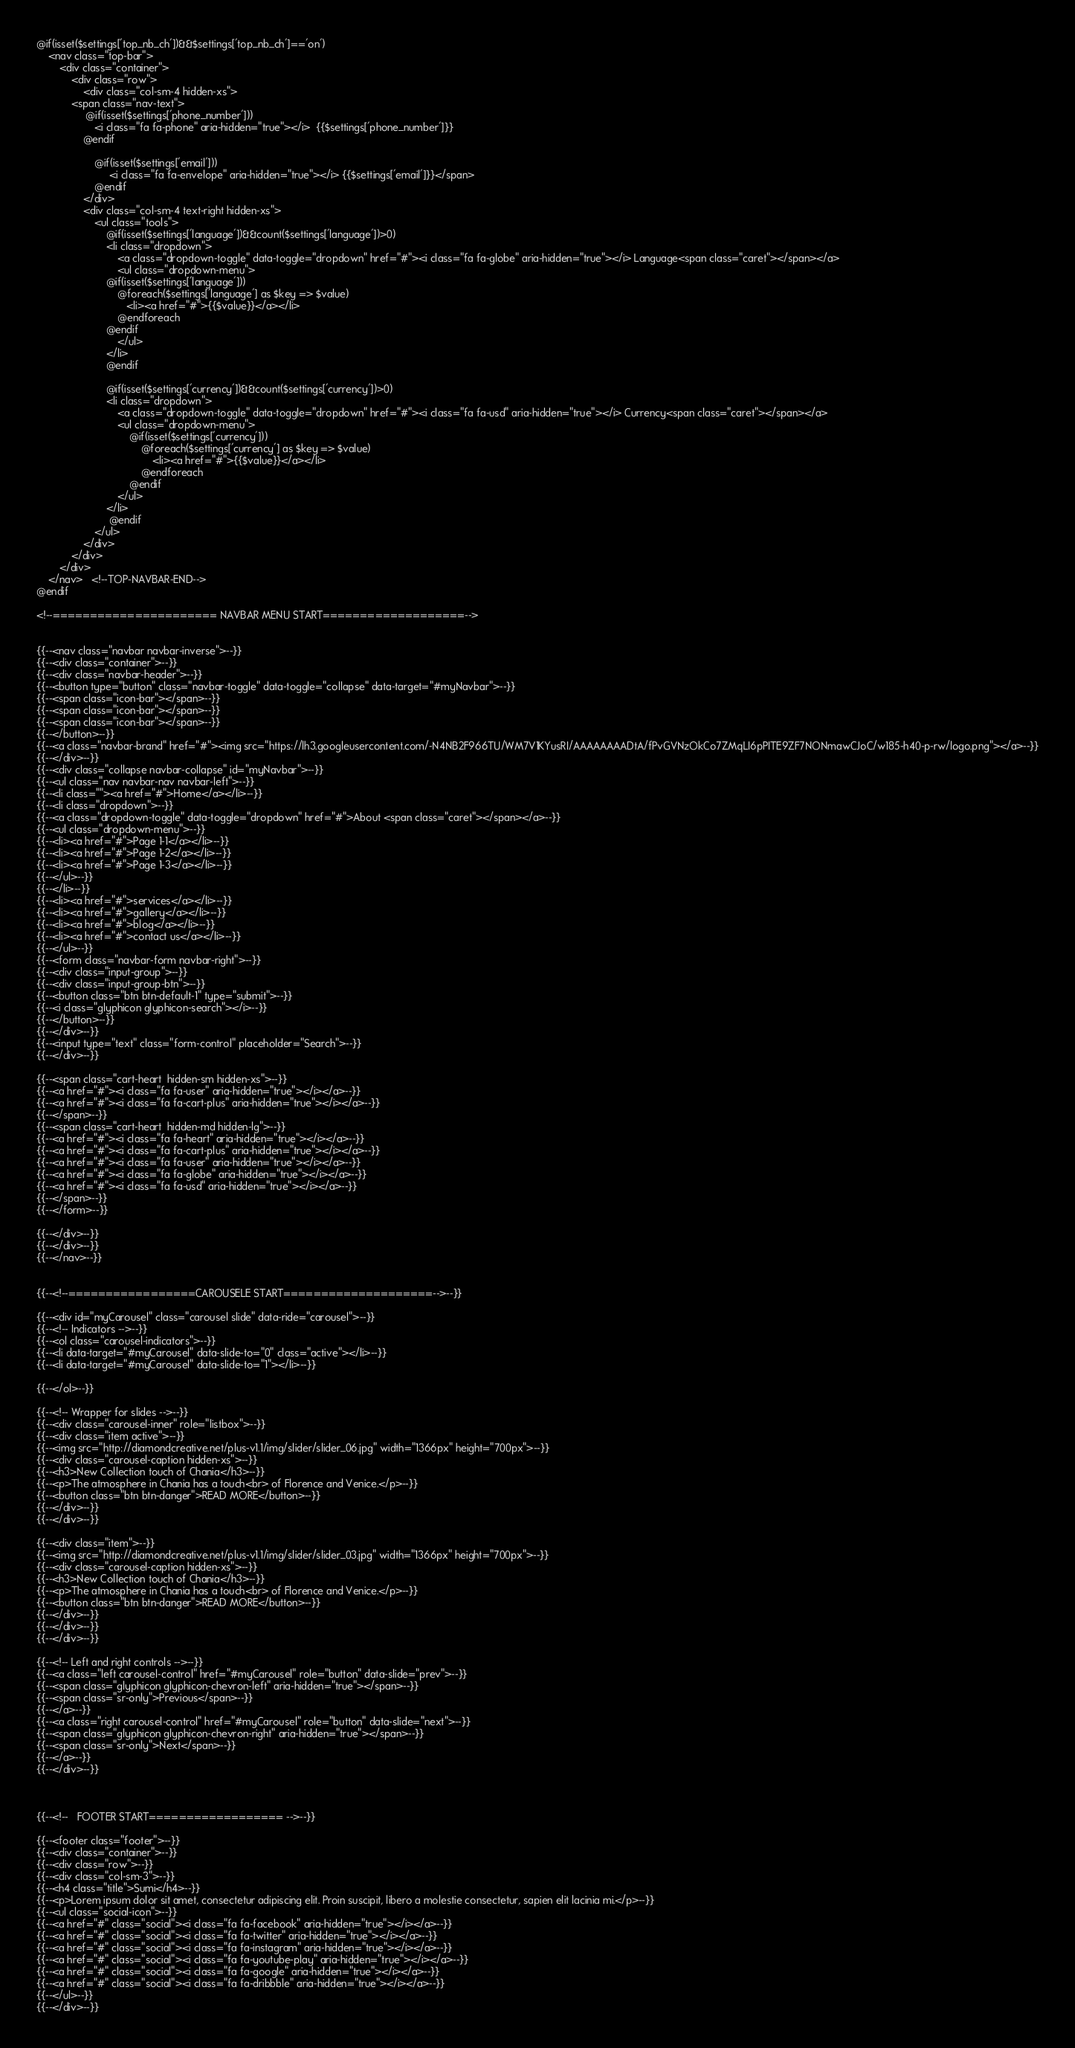Convert code to text. <code><loc_0><loc_0><loc_500><loc_500><_PHP_>

@if(isset($settings['top_nb_ch'])&&$settings['top_nb_ch']=='on')
    <nav class="top-bar">
        <div class="container">
            <div class="row">
                <div class="col-sm-4 hidden-xs">
            <span class="nav-text">
                 @if(isset($settings['phone_number']))
                    <i class="fa fa-phone" aria-hidden="true"></i>  {{$settings['phone_number']}}
                @endif

                    @if(isset($settings['email']))
                         <i class="fa fa-envelope" aria-hidden="true"></i> {{$settings['email']}}</span>
                    @endif
                </div>
                <div class="col-sm-4 text-right hidden-xs">
                    <ul class="tools">
                        @if(isset($settings['language'])&&count($settings['language'])>0)
                        <li class="dropdown">
                            <a class="dropdown-toggle" data-toggle="dropdown" href="#"><i class="fa fa-globe" aria-hidden="true"></i> Language<span class="caret"></span></a>
                            <ul class="dropdown-menu">
                        @if(isset($settings['language']))
                            @foreach($settings['language'] as $key => $value)
                               <li><a href="#">{{$value}}</a></li>
                            @endforeach
                        @endif
                            </ul>
                        </li>
                        @endif

                        @if(isset($settings['currency'])&&count($settings['currency'])>0)
                        <li class="dropdown">
                            <a class="dropdown-toggle" data-toggle="dropdown" href="#"><i class="fa fa-usd" aria-hidden="true"></i> Currency<span class="caret"></span></a>
                            <ul class="dropdown-menu">
                                @if(isset($settings['currency']))
                                    @foreach($settings['currency'] as $key => $value)
                                        <li><a href="#">{{$value}}</a></li>
                                    @endforeach
                                @endif
                            </ul>
                        </li>
                         @endif
                    </ul>
                </div>
            </div>
        </div>
    </nav>   <!--TOP-NAVBAR-END-->
@endif

<!--====================== NAVBAR MENU START===================-->


{{--<nav class="navbar navbar-inverse">--}}
{{--<div class="container">--}}
{{--<div class="navbar-header">--}}
{{--<button type="button" class="navbar-toggle" data-toggle="collapse" data-target="#myNavbar">--}}
{{--<span class="icon-bar"></span>--}}
{{--<span class="icon-bar"></span>--}}
{{--<span class="icon-bar"></span>--}}
{{--</button>--}}
{{--<a class="navbar-brand" href="#"><img src="https://lh3.googleusercontent.com/-N4NB2F966TU/WM7V1KYusRI/AAAAAAAADtA/fPvGVNzOkCo7ZMqLI6pPITE9ZF7NONmawCJoC/w185-h40-p-rw/logo.png"></a>--}}
{{--</div>--}}
{{--<div class="collapse navbar-collapse" id="myNavbar">--}}
{{--<ul class="nav navbar-nav navbar-left">--}}
{{--<li class=""><a href="#">Home</a></li>--}}
{{--<li class="dropdown">--}}
{{--<a class="dropdown-toggle" data-toggle="dropdown" href="#">About <span class="caret"></span></a>--}}
{{--<ul class="dropdown-menu">--}}
{{--<li><a href="#">Page 1-1</a></li>--}}
{{--<li><a href="#">Page 1-2</a></li>--}}
{{--<li><a href="#">Page 1-3</a></li>--}}
{{--</ul>--}}
{{--</li>--}}
{{--<li><a href="#">services</a></li>--}}
{{--<li><a href="#">gallery</a></li>--}}
{{--<li><a href="#">blog</a></li>--}}
{{--<li><a href="#">contact us</a></li>--}}
{{--</ul>--}}
{{--<form class="navbar-form navbar-right">--}}
{{--<div class="input-group">--}}
{{--<div class="input-group-btn">--}}
{{--<button class="btn btn-default-1" type="submit">--}}
{{--<i class="glyphicon glyphicon-search"></i>--}}
{{--</button>--}}
{{--</div>--}}
{{--<input type="text" class="form-control" placeholder="Search">--}}
{{--</div>--}}

{{--<span class="cart-heart  hidden-sm hidden-xs">--}}
{{--<a href="#"><i class="fa fa-user" aria-hidden="true"></i></a>--}}
{{--<a href="#"><i class="fa fa-cart-plus" aria-hidden="true"></i></a>--}}
{{--</span>--}}
{{--<span class="cart-heart  hidden-md hidden-lg">--}}
{{--<a href="#"><i class="fa fa-heart" aria-hidden="true"></i></a>--}}
{{--<a href="#"><i class="fa fa-cart-plus" aria-hidden="true"></i></a>--}}
{{--<a href="#"><i class="fa fa-user" aria-hidden="true"></i></a>--}}
{{--<a href="#"><i class="fa fa-globe" aria-hidden="true"></i></a>--}}
{{--<a href="#"><i class="fa fa-usd" aria-hidden="true"></i></a>--}}
{{--</span>--}}
{{--</form>--}}

{{--</div>--}}
{{--</div>--}}
{{--</nav>--}}


{{--<!--=================CAROUSELE START====================-->--}}

{{--<div id="myCarousel" class="carousel slide" data-ride="carousel">--}}
{{--<!-- Indicators -->--}}
{{--<ol class="carousel-indicators">--}}
{{--<li data-target="#myCarousel" data-slide-to="0" class="active"></li>--}}
{{--<li data-target="#myCarousel" data-slide-to="1"></li>--}}

{{--</ol>--}}

{{--<!-- Wrapper for slides -->--}}
{{--<div class="carousel-inner" role="listbox">--}}
{{--<div class="item active">--}}
{{--<img src="http://diamondcreative.net/plus-v1.1/img/slider/slider_06.jpg" width="1366px" height="700px">--}}
{{--<div class="carousel-caption hidden-xs">--}}
{{--<h3>New Collection touch of Chania</h3>--}}
{{--<p>The atmosphere in Chania has a touch<br> of Florence and Venice.</p>--}}
{{--<button class="btn btn-danger">READ MORE</button>--}}
{{--</div>--}}
{{--</div>--}}

{{--<div class="item">--}}
{{--<img src="http://diamondcreative.net/plus-v1.1/img/slider/slider_03.jpg" width="1366px" height="700px">--}}
{{--<div class="carousel-caption hidden-xs">--}}
{{--<h3>New Collection touch of Chania</h3>--}}
{{--<p>The atmosphere in Chania has a touch<br> of Florence and Venice.</p>--}}
{{--<button class="btn btn-danger">READ MORE</button>--}}
{{--</div>--}}
{{--</div>--}}
{{--</div>--}}

{{--<!-- Left and right controls -->--}}
{{--<a class="left carousel-control" href="#myCarousel" role="button" data-slide="prev">--}}
{{--<span class="glyphicon glyphicon-chevron-left" aria-hidden="true"></span>--}}
{{--<span class="sr-only">Previous</span>--}}
{{--</a>--}}
{{--<a class="right carousel-control" href="#myCarousel" role="button" data-slide="next">--}}
{{--<span class="glyphicon glyphicon-chevron-right" aria-hidden="true"></span>--}}
{{--<span class="sr-only">Next</span>--}}
{{--</a>--}}
{{--</div>--}}



{{--<!--   FOOTER START================== -->--}}

{{--<footer class="footer">--}}
{{--<div class="container">--}}
{{--<div class="row">--}}
{{--<div class="col-sm-3">--}}
{{--<h4 class="title">Sumi</h4>--}}
{{--<p>Lorem ipsum dolor sit amet, consectetur adipiscing elit. Proin suscipit, libero a molestie consectetur, sapien elit lacinia mi.</p>--}}
{{--<ul class="social-icon">--}}
{{--<a href="#" class="social"><i class="fa fa-facebook" aria-hidden="true"></i></a>--}}
{{--<a href="#" class="social"><i class="fa fa-twitter" aria-hidden="true"></i></a>--}}
{{--<a href="#" class="social"><i class="fa fa-instagram" aria-hidden="true"></i></a>--}}
{{--<a href="#" class="social"><i class="fa fa-youtube-play" aria-hidden="true"></i></a>--}}
{{--<a href="#" class="social"><i class="fa fa-google" aria-hidden="true"></i></a>--}}
{{--<a href="#" class="social"><i class="fa fa-dribbble" aria-hidden="true"></i></a>--}}
{{--</ul>--}}
{{--</div>--}}</code> 